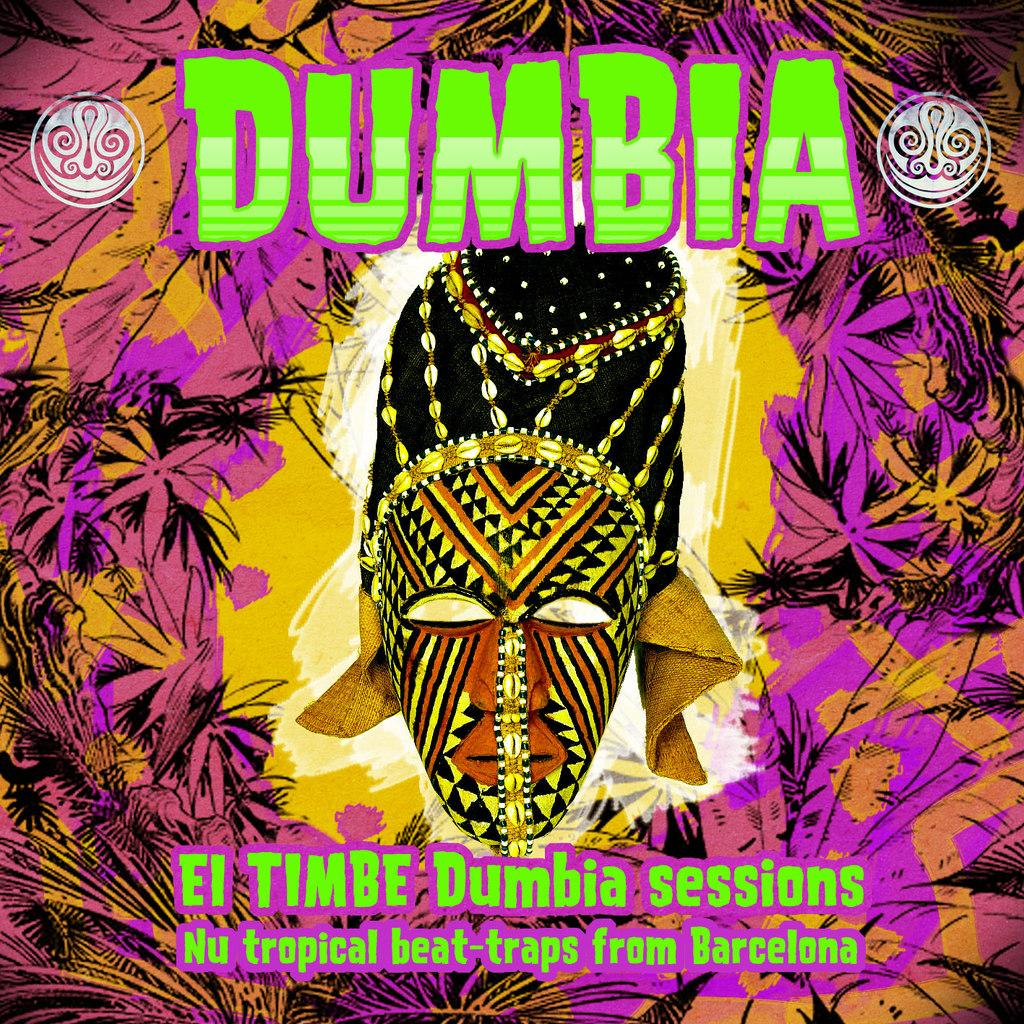What is the main subject of the painting in the image? There is a painting of a mask in the image. What type of natural elements can be seen in the image? There are leaves depicted in the image. Can you describe any other elements in the image besides the mask and leaves? There are other unspecified things in the image. Is there any text present in the image? Yes, there is writing on the image. What type of duck is swimming in the water near the mask in the image? There is no duck present in the image; it features a painting of a mask and leaves. Can you tell me how many porters are carrying the mask in the image? There are no porters present in the image; it is a painting of a mask with leaves and writing. 